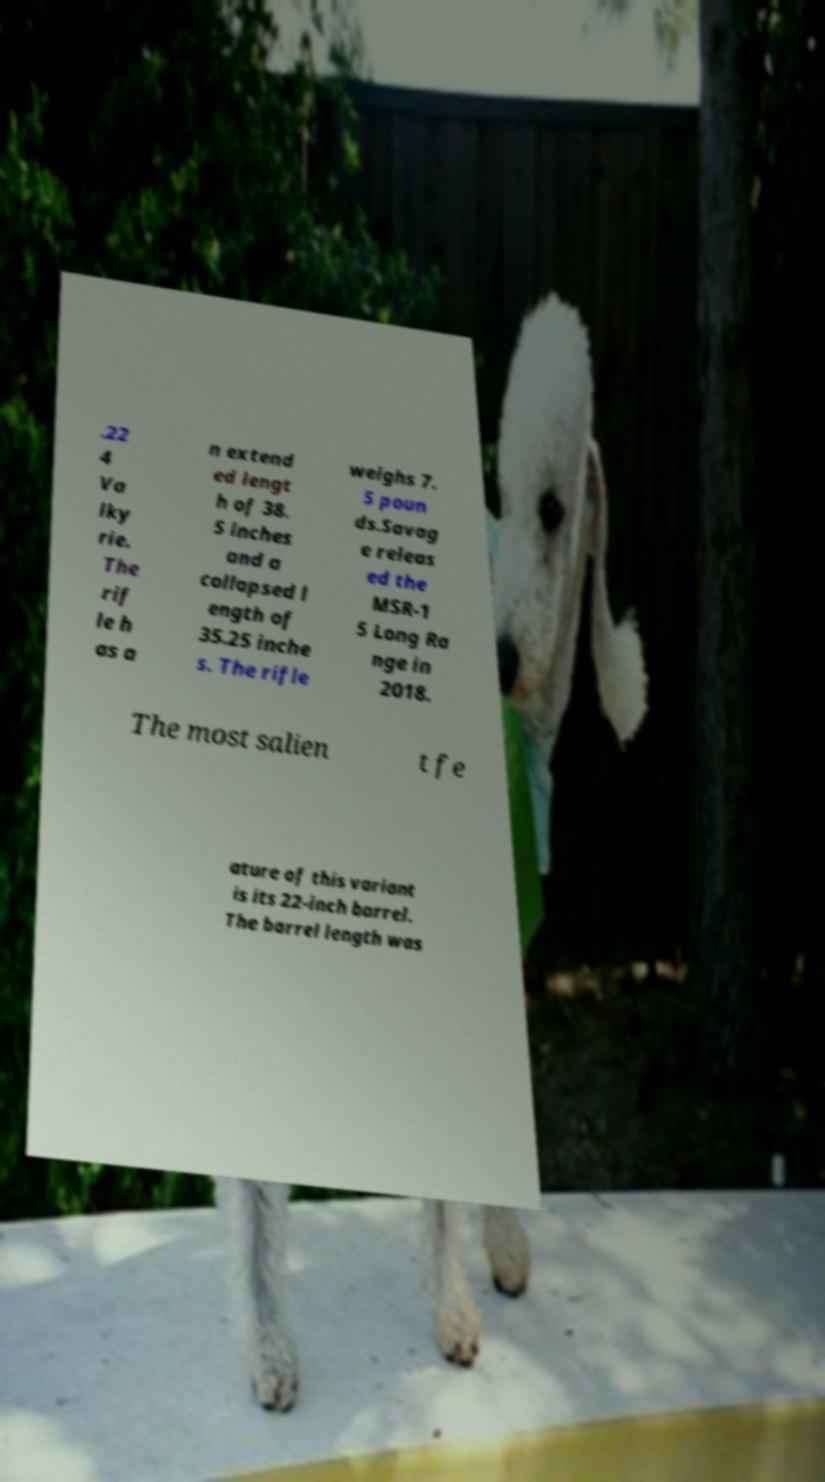Could you assist in decoding the text presented in this image and type it out clearly? .22 4 Va lky rie. The rif le h as a n extend ed lengt h of 38. 5 inches and a collapsed l ength of 35.25 inche s. The rifle weighs 7. 5 poun ds.Savag e releas ed the MSR-1 5 Long Ra nge in 2018. The most salien t fe ature of this variant is its 22-inch barrel. The barrel length was 